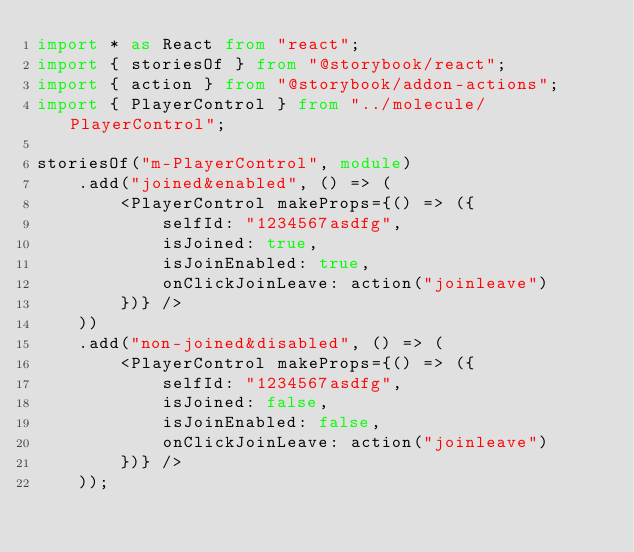<code> <loc_0><loc_0><loc_500><loc_500><_TypeScript_>import * as React from "react";
import { storiesOf } from "@storybook/react";
import { action } from "@storybook/addon-actions";
import { PlayerControl } from "../molecule/PlayerControl";

storiesOf("m-PlayerControl", module)
	.add("joined&enabled", () => (
		<PlayerControl makeProps={() => ({
			selfId: "1234567asdfg",
			isJoined: true,
			isJoinEnabled: true,
			onClickJoinLeave: action("joinleave")
		})} />
	))
	.add("non-joined&disabled", () => (
		<PlayerControl makeProps={() => ({
			selfId: "1234567asdfg",
			isJoined: false,
			isJoinEnabled: false,
			onClickJoinLeave: action("joinleave")
		})} />
	));
</code> 